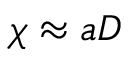<formula> <loc_0><loc_0><loc_500><loc_500>\chi \approx a D</formula> 